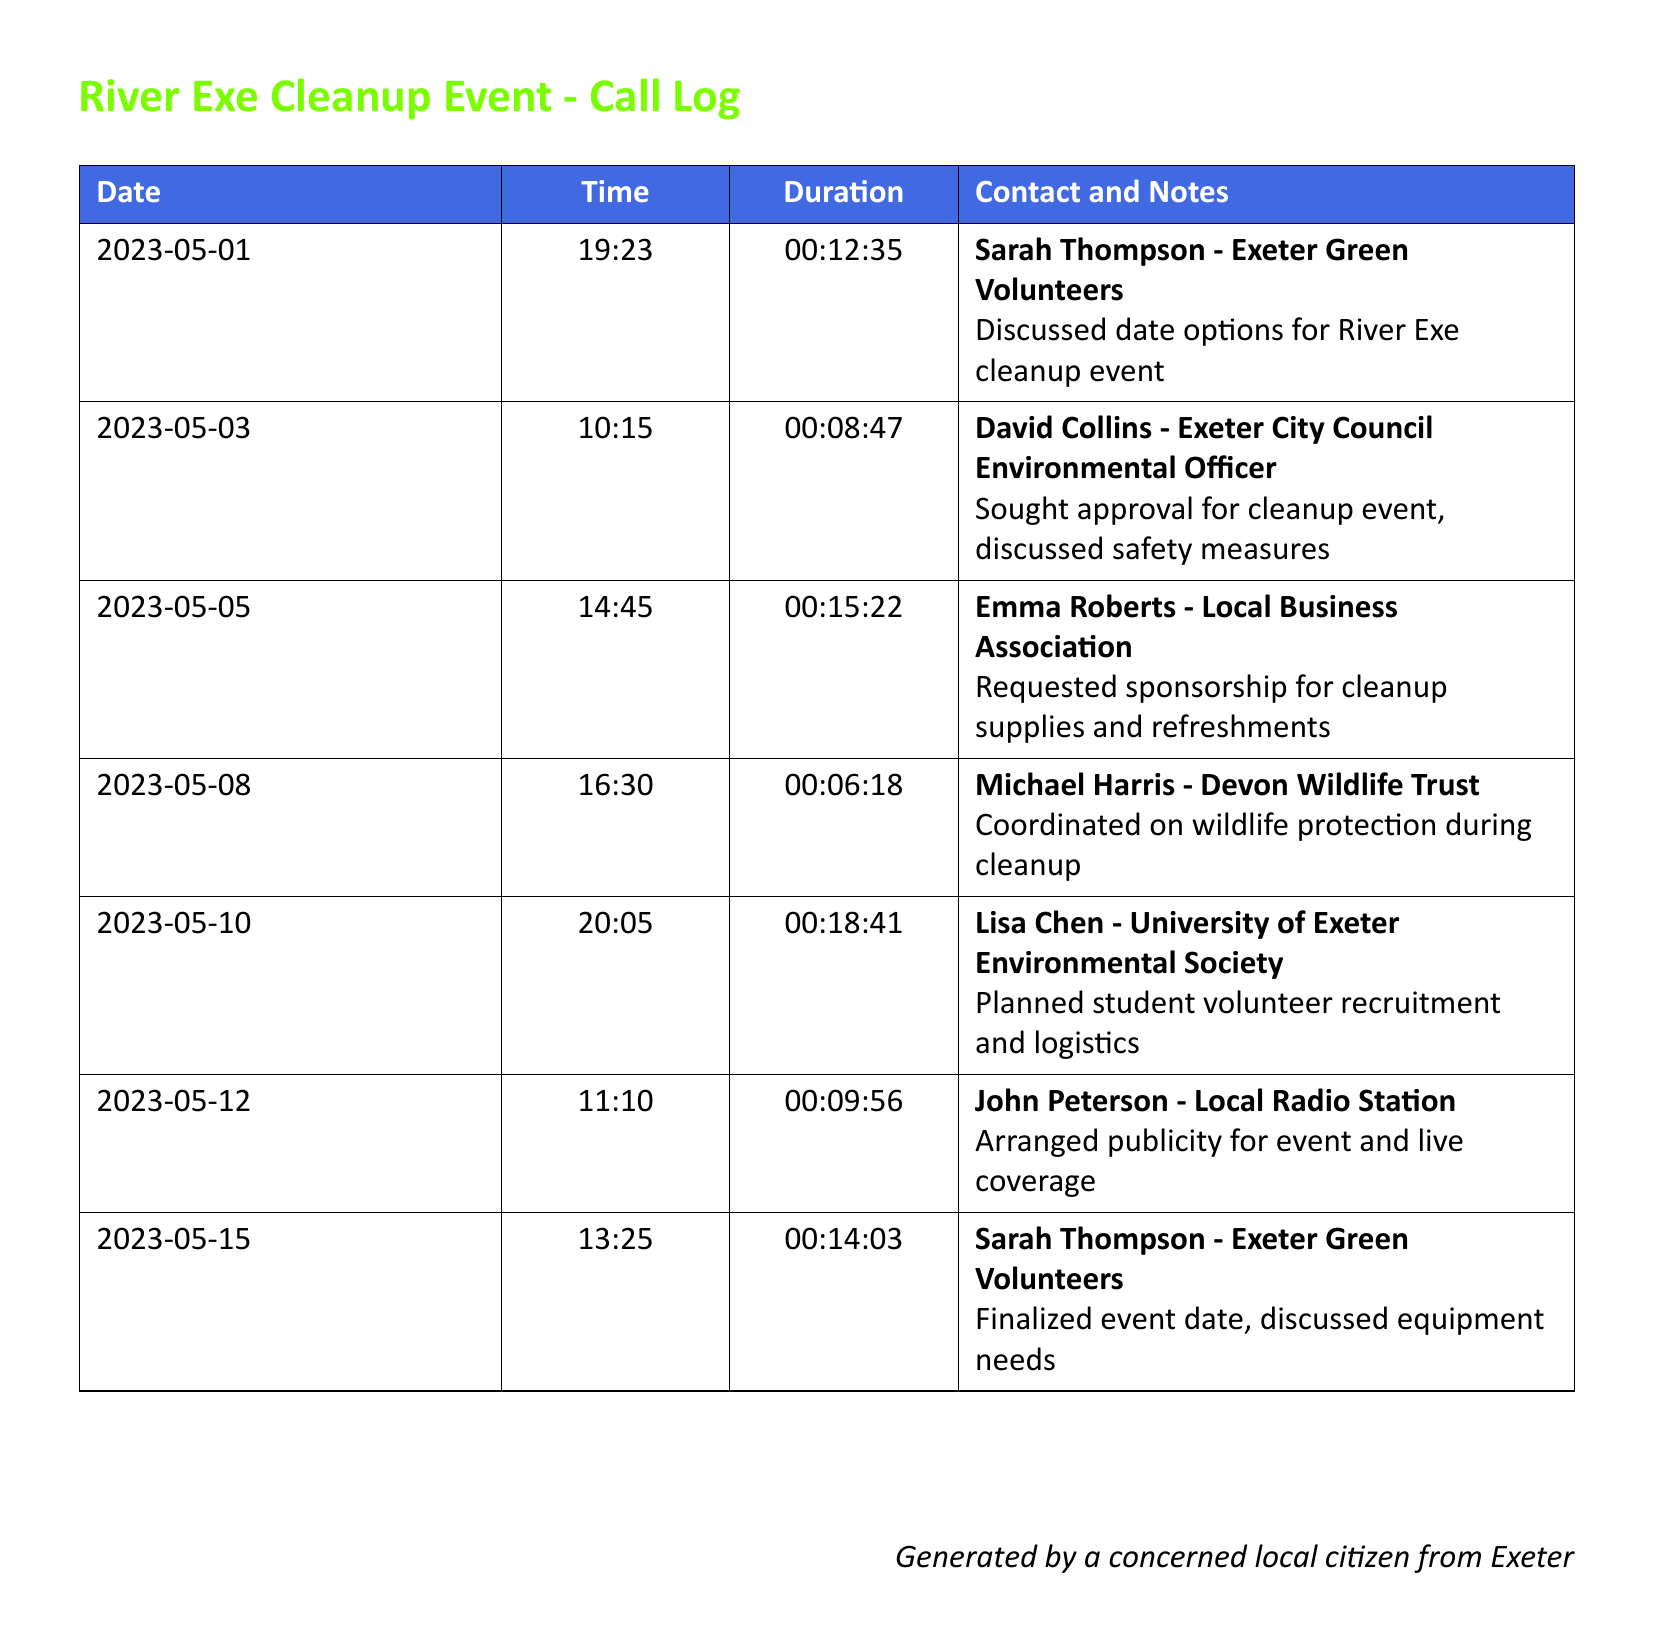what is the date of the first recorded call? The first recorded call is dated May 1, 2023, as shown in the call log.
Answer: May 1, 2023 who did the citizen speak with on May 5, 2023? On May 5, 2023, the citizen spoke with Emma Roberts, as indicated in the document.
Answer: Emma Roberts how long was the call with David Collins? The duration of the call with David Collins was 8 minutes and 47 seconds, which is detailed in the call log.
Answer: 00:08:47 what is the purpose of the call on May 12, 2023? The call on May 12, 2023, was arranged to discuss publicity for the event, as noted in the records.
Answer: Publicity for event how many calls were made in total? The total number of calls listed in the call log is seven, covering different contacts related to the cleanup event.
Answer: 7 which contact is associated with the University of Exeter? The contact associated with the University of Exeter is Lisa Chen, as mentioned in the log.
Answer: Lisa Chen what was discussed in the call with Michael Harris? The discussion with Michael Harris was about coordinating on wildlife protection during the cleanup event, as specified.
Answer: Wildlife protection who did the citizen contact for sponsorship? The citizen contacted Emma Roberts for sponsorship, as indicated in the call log details.
Answer: Emma Roberts what time was the call with Sarah Thompson on May 15, 2023? The call with Sarah Thompson on May 15, 2023, was made at 1:25 PM as per the records.
Answer: 13:25 